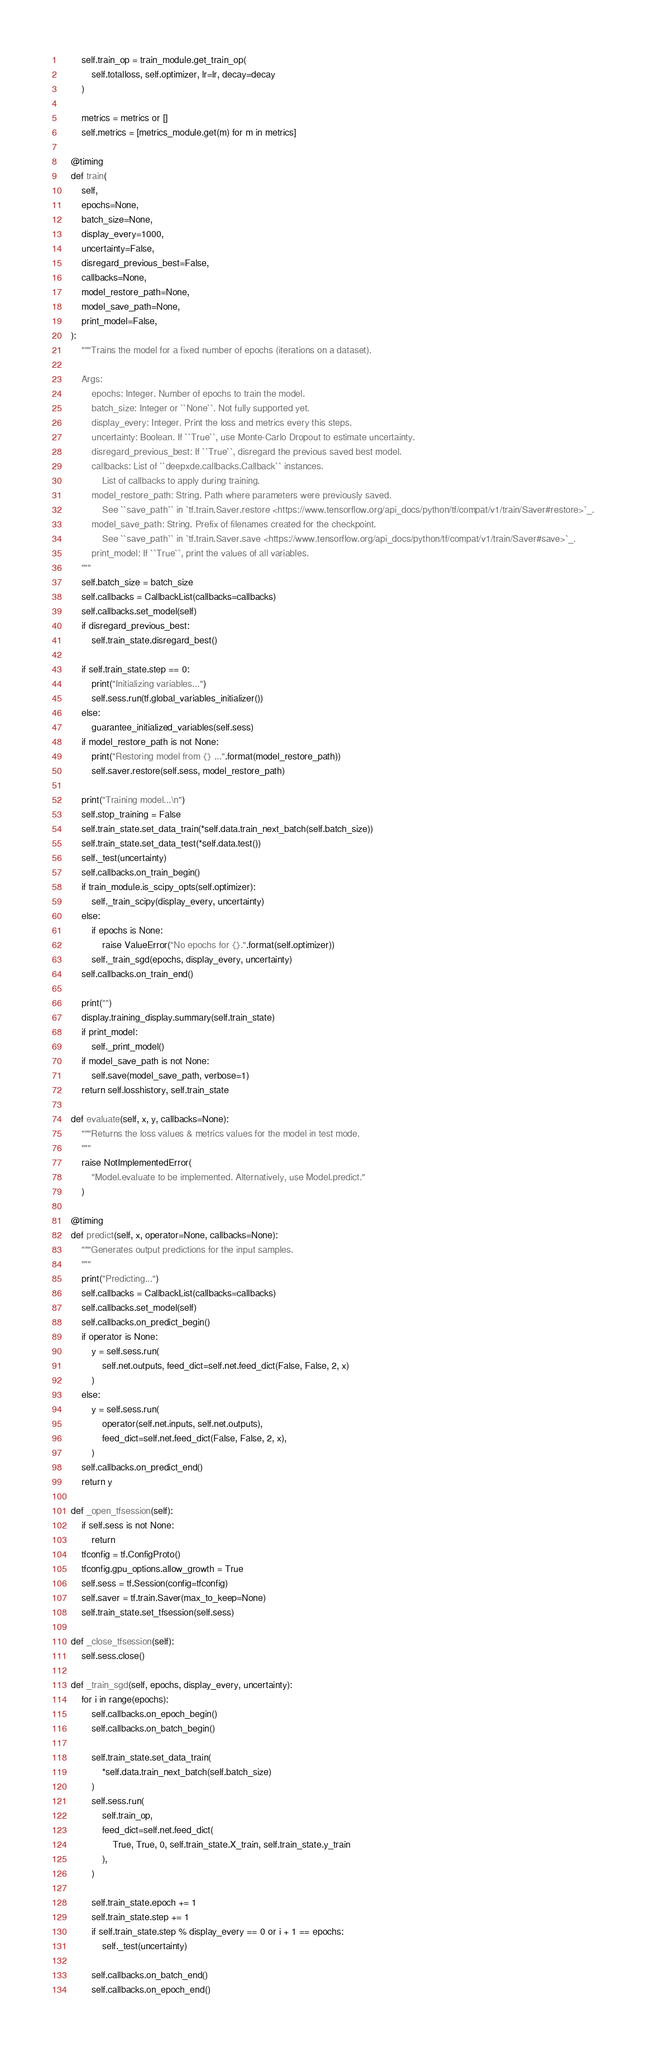<code> <loc_0><loc_0><loc_500><loc_500><_Python_>        self.train_op = train_module.get_train_op(
            self.totalloss, self.optimizer, lr=lr, decay=decay
        )

        metrics = metrics or []
        self.metrics = [metrics_module.get(m) for m in metrics]

    @timing
    def train(
        self,
        epochs=None,
        batch_size=None,
        display_every=1000,
        uncertainty=False,
        disregard_previous_best=False,
        callbacks=None,
        model_restore_path=None,
        model_save_path=None,
        print_model=False,
    ):
        """Trains the model for a fixed number of epochs (iterations on a dataset).

        Args:
            epochs: Integer. Number of epochs to train the model.
            batch_size: Integer or ``None``. Not fully supported yet.
            display_every: Integer. Print the loss and metrics every this steps.
            uncertainty: Boolean. If ``True``, use Monte-Carlo Dropout to estimate uncertainty.
            disregard_previous_best: If ``True``, disregard the previous saved best model.
            callbacks: List of ``deepxde.callbacks.Callback`` instances.
                List of callbacks to apply during training.
            model_restore_path: String. Path where parameters were previously saved.
                See ``save_path`` in `tf.train.Saver.restore <https://www.tensorflow.org/api_docs/python/tf/compat/v1/train/Saver#restore>`_.
            model_save_path: String. Prefix of filenames created for the checkpoint.
                See ``save_path`` in `tf.train.Saver.save <https://www.tensorflow.org/api_docs/python/tf/compat/v1/train/Saver#save>`_.
            print_model: If ``True``, print the values of all variables.
        """
        self.batch_size = batch_size
        self.callbacks = CallbackList(callbacks=callbacks)
        self.callbacks.set_model(self)
        if disregard_previous_best:
            self.train_state.disregard_best()

        if self.train_state.step == 0:
            print("Initializing variables...")
            self.sess.run(tf.global_variables_initializer())
        else:
            guarantee_initialized_variables(self.sess)
        if model_restore_path is not None:
            print("Restoring model from {} ...".format(model_restore_path))
            self.saver.restore(self.sess, model_restore_path)

        print("Training model...\n")
        self.stop_training = False
        self.train_state.set_data_train(*self.data.train_next_batch(self.batch_size))
        self.train_state.set_data_test(*self.data.test())
        self._test(uncertainty)
        self.callbacks.on_train_begin()
        if train_module.is_scipy_opts(self.optimizer):
            self._train_scipy(display_every, uncertainty)
        else:
            if epochs is None:
                raise ValueError("No epochs for {}.".format(self.optimizer))
            self._train_sgd(epochs, display_every, uncertainty)
        self.callbacks.on_train_end()

        print("")
        display.training_display.summary(self.train_state)
        if print_model:
            self._print_model()
        if model_save_path is not None:
            self.save(model_save_path, verbose=1)
        return self.losshistory, self.train_state

    def evaluate(self, x, y, callbacks=None):
        """Returns the loss values & metrics values for the model in test mode.
        """
        raise NotImplementedError(
            "Model.evaluate to be implemented. Alternatively, use Model.predict."
        )

    @timing
    def predict(self, x, operator=None, callbacks=None):
        """Generates output predictions for the input samples.
        """
        print("Predicting...")
        self.callbacks = CallbackList(callbacks=callbacks)
        self.callbacks.set_model(self)
        self.callbacks.on_predict_begin()
        if operator is None:
            y = self.sess.run(
                self.net.outputs, feed_dict=self.net.feed_dict(False, False, 2, x)
            )
        else:
            y = self.sess.run(
                operator(self.net.inputs, self.net.outputs),
                feed_dict=self.net.feed_dict(False, False, 2, x),
            )
        self.callbacks.on_predict_end()
        return y

    def _open_tfsession(self):
        if self.sess is not None:
            return
        tfconfig = tf.ConfigProto()
        tfconfig.gpu_options.allow_growth = True
        self.sess = tf.Session(config=tfconfig)
        self.saver = tf.train.Saver(max_to_keep=None)
        self.train_state.set_tfsession(self.sess)

    def _close_tfsession(self):
        self.sess.close()

    def _train_sgd(self, epochs, display_every, uncertainty):
        for i in range(epochs):
            self.callbacks.on_epoch_begin()
            self.callbacks.on_batch_begin()

            self.train_state.set_data_train(
                *self.data.train_next_batch(self.batch_size)
            )
            self.sess.run(
                self.train_op,
                feed_dict=self.net.feed_dict(
                    True, True, 0, self.train_state.X_train, self.train_state.y_train
                ),
            )

            self.train_state.epoch += 1
            self.train_state.step += 1
            if self.train_state.step % display_every == 0 or i + 1 == epochs:
                self._test(uncertainty)

            self.callbacks.on_batch_end()
            self.callbacks.on_epoch_end()
</code> 